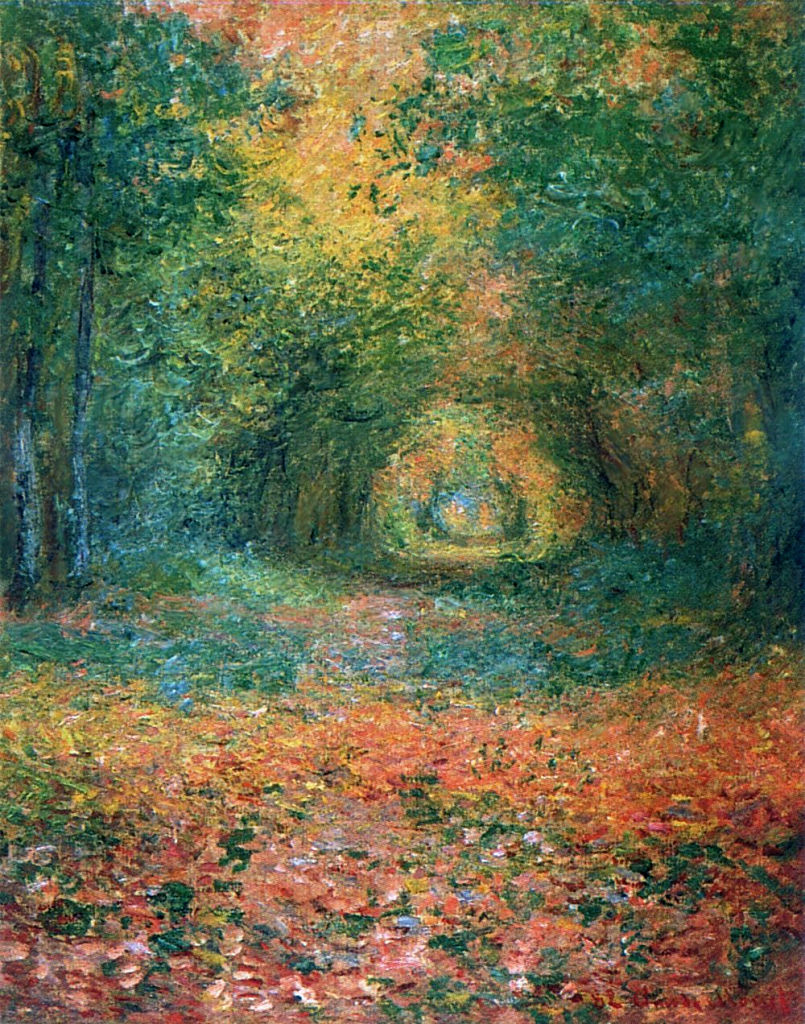Write a detailed description of the given image.
 This image is an impressionist painting that captures a serene forest path. The path, blanketed in fallen leaves, meanders through the heart of the forest, inviting viewers into its tranquility. The forest is brought to life with a palette dominated by shades of green and orange, punctuated by occasional accents of blue and yellow. The artist's loose brushstrokes contribute to the impressionistic style of the painting, creating a sense of movement and vitality. Despite the vibrancy of the colors and brushwork, the overall mood of the painting is peaceful and serene, reflecting the quiet beauty of nature. 